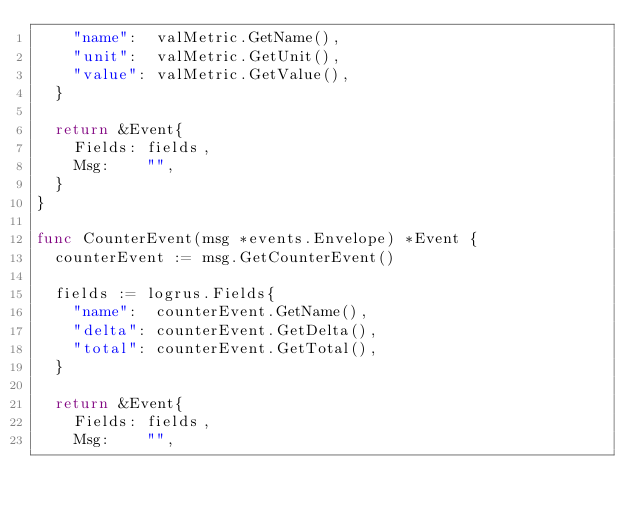Convert code to text. <code><loc_0><loc_0><loc_500><loc_500><_Go_>		"name":  valMetric.GetName(),
		"unit":  valMetric.GetUnit(),
		"value": valMetric.GetValue(),
	}

	return &Event{
		Fields: fields,
		Msg:    "",
	}
}

func CounterEvent(msg *events.Envelope) *Event {
	counterEvent := msg.GetCounterEvent()

	fields := logrus.Fields{
		"name":  counterEvent.GetName(),
		"delta": counterEvent.GetDelta(),
		"total": counterEvent.GetTotal(),
	}

	return &Event{
		Fields: fields,
		Msg:    "",</code> 